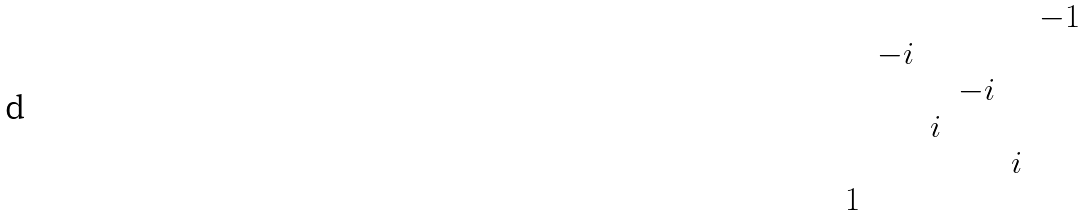Convert formula to latex. <formula><loc_0><loc_0><loc_500><loc_500>\begin{matrix} & & & & & - 1 \\ & - i & & & & \\ & & & - i & & \\ & & i & & & \\ & & & & i & \\ 1 & & & & & \end{matrix}</formula> 